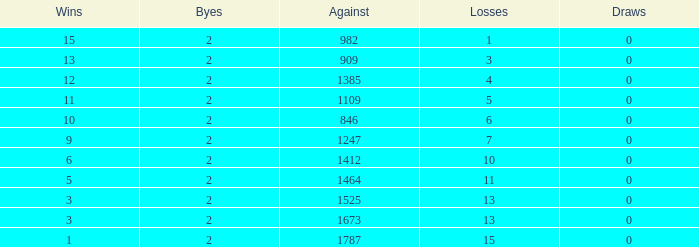What is the highest number listed under against when there were less than 3 wins and less than 15 losses? None. 